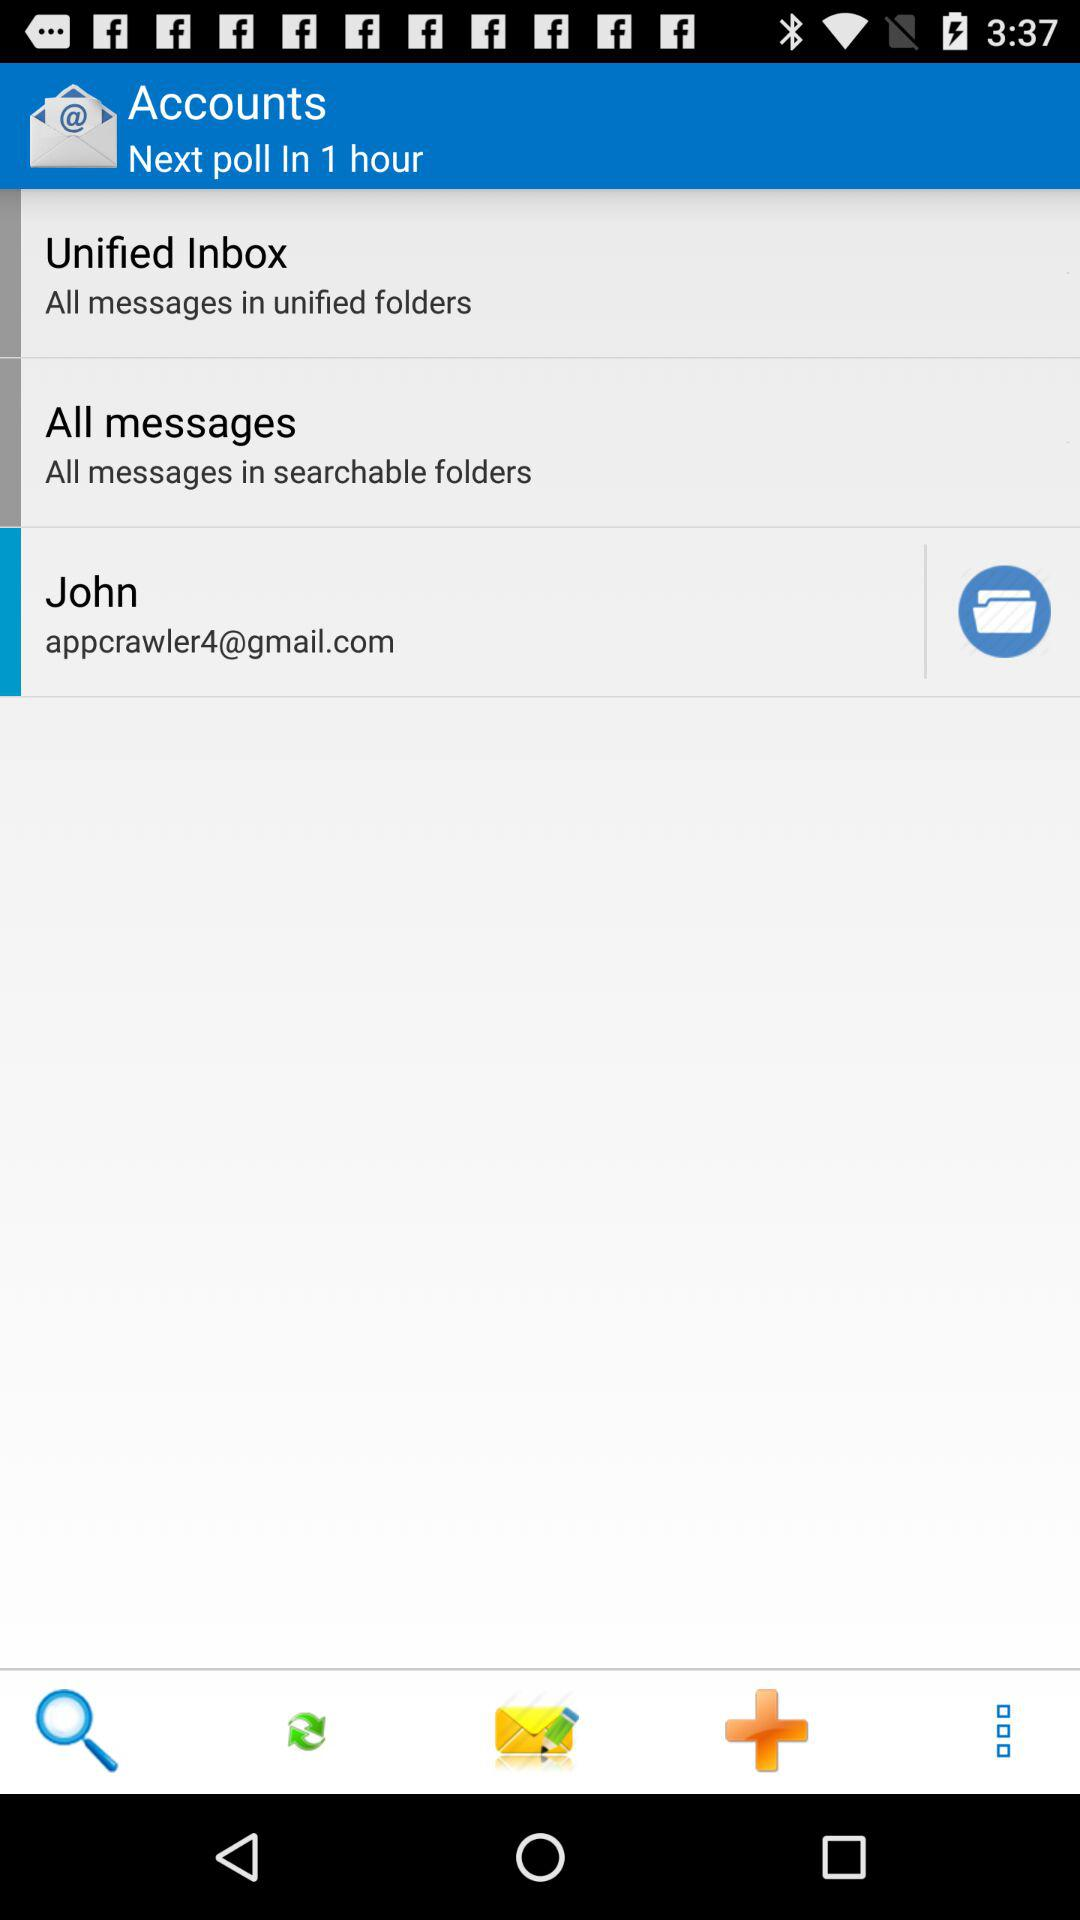What is the name of the user? The name of the user is John. 